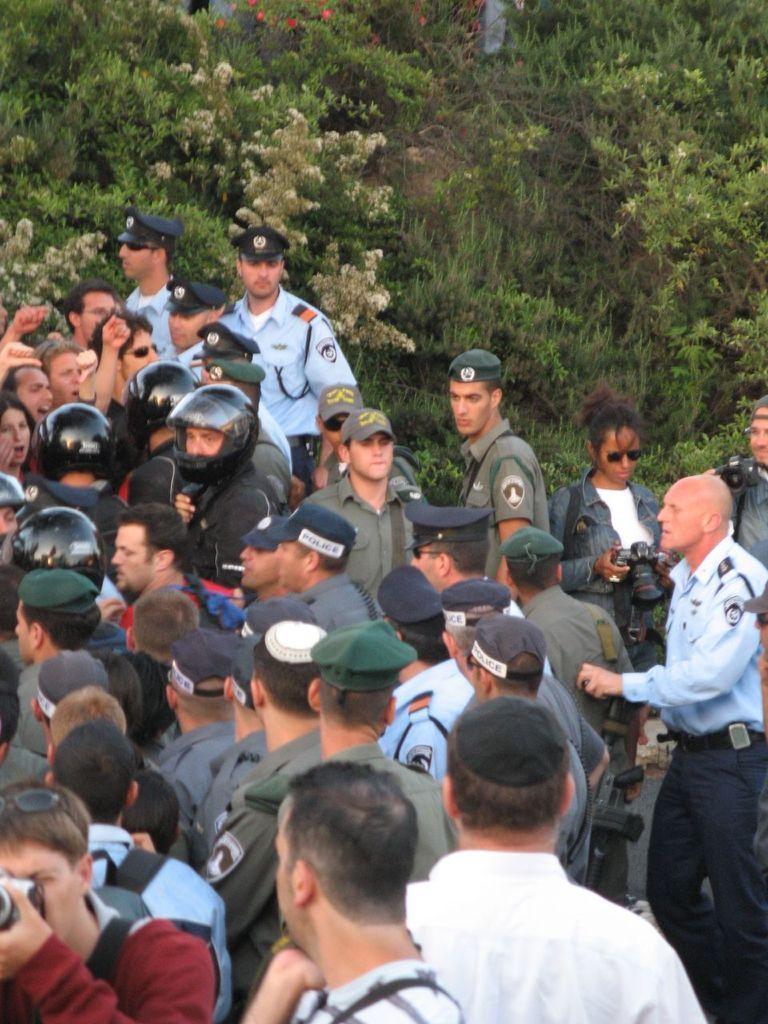Can you describe this image briefly? In this image we can see a group of people, among them some people are wearing caps and some are holding the cameras, in the background we can see some plants and flowers. 